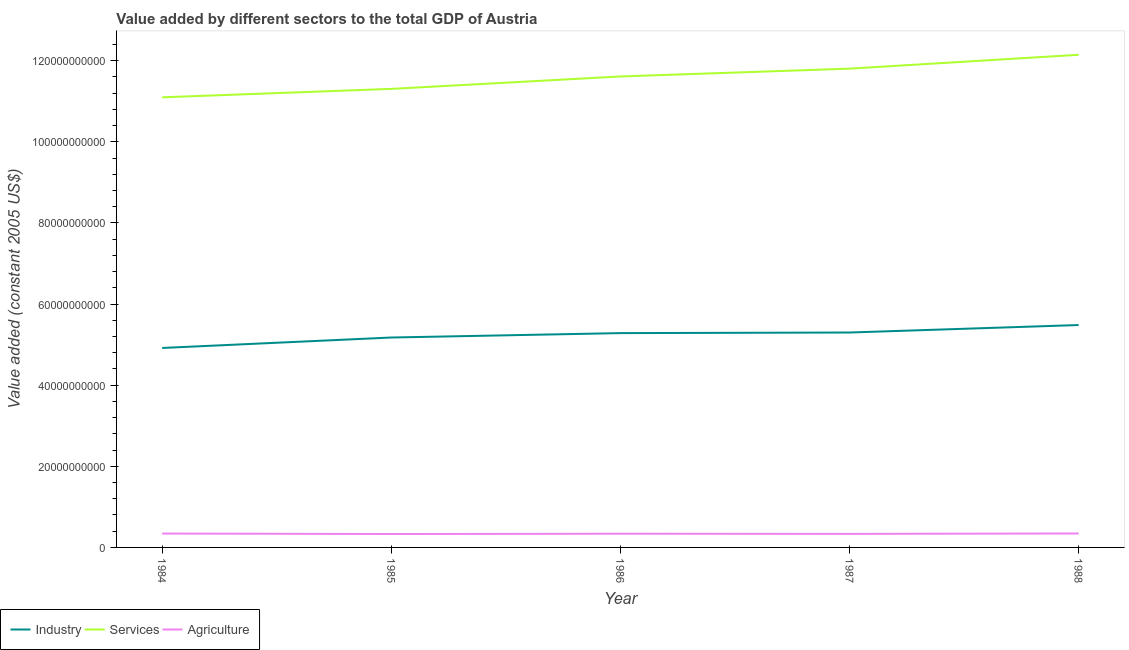How many different coloured lines are there?
Keep it short and to the point. 3. Does the line corresponding to value added by agricultural sector intersect with the line corresponding to value added by services?
Your answer should be very brief. No. What is the value added by industrial sector in 1987?
Provide a short and direct response. 5.30e+1. Across all years, what is the maximum value added by agricultural sector?
Your answer should be compact. 3.44e+09. Across all years, what is the minimum value added by services?
Offer a terse response. 1.11e+11. In which year was the value added by industrial sector minimum?
Offer a terse response. 1984. What is the total value added by agricultural sector in the graph?
Your response must be concise. 1.69e+1. What is the difference between the value added by industrial sector in 1986 and that in 1988?
Your response must be concise. -1.99e+09. What is the difference between the value added by industrial sector in 1985 and the value added by agricultural sector in 1987?
Make the answer very short. 4.84e+1. What is the average value added by industrial sector per year?
Provide a short and direct response. 5.23e+1. In the year 1987, what is the difference between the value added by industrial sector and value added by services?
Give a very brief answer. -6.51e+1. What is the ratio of the value added by agricultural sector in 1984 to that in 1987?
Your answer should be compact. 1.02. Is the difference between the value added by industrial sector in 1984 and 1985 greater than the difference between the value added by services in 1984 and 1985?
Ensure brevity in your answer.  No. What is the difference between the highest and the second highest value added by industrial sector?
Ensure brevity in your answer.  1.84e+09. What is the difference between the highest and the lowest value added by industrial sector?
Ensure brevity in your answer.  5.65e+09. Is it the case that in every year, the sum of the value added by industrial sector and value added by services is greater than the value added by agricultural sector?
Provide a succinct answer. Yes. Is the value added by services strictly greater than the value added by agricultural sector over the years?
Your response must be concise. Yes. Is the value added by services strictly less than the value added by agricultural sector over the years?
Keep it short and to the point. No. How many years are there in the graph?
Ensure brevity in your answer.  5. Are the values on the major ticks of Y-axis written in scientific E-notation?
Your answer should be compact. No. Where does the legend appear in the graph?
Make the answer very short. Bottom left. What is the title of the graph?
Provide a short and direct response. Value added by different sectors to the total GDP of Austria. Does "Infant(male)" appear as one of the legend labels in the graph?
Offer a very short reply. No. What is the label or title of the X-axis?
Provide a short and direct response. Year. What is the label or title of the Y-axis?
Provide a short and direct response. Value added (constant 2005 US$). What is the Value added (constant 2005 US$) in Industry in 1984?
Offer a terse response. 4.92e+1. What is the Value added (constant 2005 US$) in Services in 1984?
Make the answer very short. 1.11e+11. What is the Value added (constant 2005 US$) of Agriculture in 1984?
Make the answer very short. 3.42e+09. What is the Value added (constant 2005 US$) of Industry in 1985?
Your answer should be compact. 5.18e+1. What is the Value added (constant 2005 US$) in Services in 1985?
Ensure brevity in your answer.  1.13e+11. What is the Value added (constant 2005 US$) of Agriculture in 1985?
Keep it short and to the point. 3.31e+09. What is the Value added (constant 2005 US$) in Industry in 1986?
Offer a very short reply. 5.28e+1. What is the Value added (constant 2005 US$) in Services in 1986?
Ensure brevity in your answer.  1.16e+11. What is the Value added (constant 2005 US$) of Agriculture in 1986?
Offer a terse response. 3.37e+09. What is the Value added (constant 2005 US$) in Industry in 1987?
Offer a terse response. 5.30e+1. What is the Value added (constant 2005 US$) in Services in 1987?
Ensure brevity in your answer.  1.18e+11. What is the Value added (constant 2005 US$) of Agriculture in 1987?
Ensure brevity in your answer.  3.34e+09. What is the Value added (constant 2005 US$) of Industry in 1988?
Your response must be concise. 5.48e+1. What is the Value added (constant 2005 US$) in Services in 1988?
Your answer should be very brief. 1.21e+11. What is the Value added (constant 2005 US$) of Agriculture in 1988?
Your answer should be very brief. 3.44e+09. Across all years, what is the maximum Value added (constant 2005 US$) of Industry?
Your answer should be very brief. 5.48e+1. Across all years, what is the maximum Value added (constant 2005 US$) of Services?
Provide a short and direct response. 1.21e+11. Across all years, what is the maximum Value added (constant 2005 US$) of Agriculture?
Ensure brevity in your answer.  3.44e+09. Across all years, what is the minimum Value added (constant 2005 US$) of Industry?
Your answer should be compact. 4.92e+1. Across all years, what is the minimum Value added (constant 2005 US$) of Services?
Give a very brief answer. 1.11e+11. Across all years, what is the minimum Value added (constant 2005 US$) in Agriculture?
Offer a very short reply. 3.31e+09. What is the total Value added (constant 2005 US$) in Industry in the graph?
Your answer should be compact. 2.62e+11. What is the total Value added (constant 2005 US$) of Services in the graph?
Your answer should be compact. 5.80e+11. What is the total Value added (constant 2005 US$) of Agriculture in the graph?
Keep it short and to the point. 1.69e+1. What is the difference between the Value added (constant 2005 US$) of Industry in 1984 and that in 1985?
Provide a short and direct response. -2.58e+09. What is the difference between the Value added (constant 2005 US$) of Services in 1984 and that in 1985?
Your response must be concise. -2.08e+09. What is the difference between the Value added (constant 2005 US$) in Agriculture in 1984 and that in 1985?
Your answer should be very brief. 1.15e+08. What is the difference between the Value added (constant 2005 US$) in Industry in 1984 and that in 1986?
Provide a short and direct response. -3.66e+09. What is the difference between the Value added (constant 2005 US$) in Services in 1984 and that in 1986?
Provide a succinct answer. -5.14e+09. What is the difference between the Value added (constant 2005 US$) of Agriculture in 1984 and that in 1986?
Your answer should be compact. 4.65e+07. What is the difference between the Value added (constant 2005 US$) in Industry in 1984 and that in 1987?
Your answer should be compact. -3.81e+09. What is the difference between the Value added (constant 2005 US$) of Services in 1984 and that in 1987?
Offer a terse response. -7.07e+09. What is the difference between the Value added (constant 2005 US$) in Agriculture in 1984 and that in 1987?
Your response must be concise. 8.17e+07. What is the difference between the Value added (constant 2005 US$) of Industry in 1984 and that in 1988?
Ensure brevity in your answer.  -5.65e+09. What is the difference between the Value added (constant 2005 US$) in Services in 1984 and that in 1988?
Your answer should be very brief. -1.05e+1. What is the difference between the Value added (constant 2005 US$) in Agriculture in 1984 and that in 1988?
Keep it short and to the point. -2.02e+07. What is the difference between the Value added (constant 2005 US$) of Industry in 1985 and that in 1986?
Your response must be concise. -1.09e+09. What is the difference between the Value added (constant 2005 US$) in Services in 1985 and that in 1986?
Keep it short and to the point. -3.06e+09. What is the difference between the Value added (constant 2005 US$) of Agriculture in 1985 and that in 1986?
Provide a succinct answer. -6.80e+07. What is the difference between the Value added (constant 2005 US$) in Industry in 1985 and that in 1987?
Ensure brevity in your answer.  -1.23e+09. What is the difference between the Value added (constant 2005 US$) of Services in 1985 and that in 1987?
Offer a terse response. -4.99e+09. What is the difference between the Value added (constant 2005 US$) in Agriculture in 1985 and that in 1987?
Offer a very short reply. -3.29e+07. What is the difference between the Value added (constant 2005 US$) in Industry in 1985 and that in 1988?
Your answer should be compact. -3.08e+09. What is the difference between the Value added (constant 2005 US$) in Services in 1985 and that in 1988?
Provide a short and direct response. -8.41e+09. What is the difference between the Value added (constant 2005 US$) in Agriculture in 1985 and that in 1988?
Ensure brevity in your answer.  -1.35e+08. What is the difference between the Value added (constant 2005 US$) in Industry in 1986 and that in 1987?
Your response must be concise. -1.45e+08. What is the difference between the Value added (constant 2005 US$) in Services in 1986 and that in 1987?
Keep it short and to the point. -1.93e+09. What is the difference between the Value added (constant 2005 US$) of Agriculture in 1986 and that in 1987?
Provide a short and direct response. 3.51e+07. What is the difference between the Value added (constant 2005 US$) in Industry in 1986 and that in 1988?
Your answer should be very brief. -1.99e+09. What is the difference between the Value added (constant 2005 US$) in Services in 1986 and that in 1988?
Ensure brevity in your answer.  -5.35e+09. What is the difference between the Value added (constant 2005 US$) of Agriculture in 1986 and that in 1988?
Provide a succinct answer. -6.68e+07. What is the difference between the Value added (constant 2005 US$) in Industry in 1987 and that in 1988?
Offer a terse response. -1.84e+09. What is the difference between the Value added (constant 2005 US$) in Services in 1987 and that in 1988?
Keep it short and to the point. -3.42e+09. What is the difference between the Value added (constant 2005 US$) of Agriculture in 1987 and that in 1988?
Offer a very short reply. -1.02e+08. What is the difference between the Value added (constant 2005 US$) of Industry in 1984 and the Value added (constant 2005 US$) of Services in 1985?
Your response must be concise. -6.39e+1. What is the difference between the Value added (constant 2005 US$) in Industry in 1984 and the Value added (constant 2005 US$) in Agriculture in 1985?
Keep it short and to the point. 4.59e+1. What is the difference between the Value added (constant 2005 US$) in Services in 1984 and the Value added (constant 2005 US$) in Agriculture in 1985?
Your answer should be compact. 1.08e+11. What is the difference between the Value added (constant 2005 US$) of Industry in 1984 and the Value added (constant 2005 US$) of Services in 1986?
Your answer should be very brief. -6.69e+1. What is the difference between the Value added (constant 2005 US$) of Industry in 1984 and the Value added (constant 2005 US$) of Agriculture in 1986?
Your response must be concise. 4.58e+1. What is the difference between the Value added (constant 2005 US$) in Services in 1984 and the Value added (constant 2005 US$) in Agriculture in 1986?
Offer a very short reply. 1.08e+11. What is the difference between the Value added (constant 2005 US$) in Industry in 1984 and the Value added (constant 2005 US$) in Services in 1987?
Offer a very short reply. -6.89e+1. What is the difference between the Value added (constant 2005 US$) in Industry in 1984 and the Value added (constant 2005 US$) in Agriculture in 1987?
Provide a succinct answer. 4.58e+1. What is the difference between the Value added (constant 2005 US$) of Services in 1984 and the Value added (constant 2005 US$) of Agriculture in 1987?
Ensure brevity in your answer.  1.08e+11. What is the difference between the Value added (constant 2005 US$) in Industry in 1984 and the Value added (constant 2005 US$) in Services in 1988?
Give a very brief answer. -7.23e+1. What is the difference between the Value added (constant 2005 US$) of Industry in 1984 and the Value added (constant 2005 US$) of Agriculture in 1988?
Make the answer very short. 4.57e+1. What is the difference between the Value added (constant 2005 US$) in Services in 1984 and the Value added (constant 2005 US$) in Agriculture in 1988?
Make the answer very short. 1.08e+11. What is the difference between the Value added (constant 2005 US$) in Industry in 1985 and the Value added (constant 2005 US$) in Services in 1986?
Your answer should be compact. -6.44e+1. What is the difference between the Value added (constant 2005 US$) of Industry in 1985 and the Value added (constant 2005 US$) of Agriculture in 1986?
Provide a short and direct response. 4.84e+1. What is the difference between the Value added (constant 2005 US$) of Services in 1985 and the Value added (constant 2005 US$) of Agriculture in 1986?
Provide a succinct answer. 1.10e+11. What is the difference between the Value added (constant 2005 US$) in Industry in 1985 and the Value added (constant 2005 US$) in Services in 1987?
Make the answer very short. -6.63e+1. What is the difference between the Value added (constant 2005 US$) of Industry in 1985 and the Value added (constant 2005 US$) of Agriculture in 1987?
Offer a terse response. 4.84e+1. What is the difference between the Value added (constant 2005 US$) of Services in 1985 and the Value added (constant 2005 US$) of Agriculture in 1987?
Provide a succinct answer. 1.10e+11. What is the difference between the Value added (constant 2005 US$) of Industry in 1985 and the Value added (constant 2005 US$) of Services in 1988?
Make the answer very short. -6.97e+1. What is the difference between the Value added (constant 2005 US$) of Industry in 1985 and the Value added (constant 2005 US$) of Agriculture in 1988?
Your answer should be very brief. 4.83e+1. What is the difference between the Value added (constant 2005 US$) in Services in 1985 and the Value added (constant 2005 US$) in Agriculture in 1988?
Your response must be concise. 1.10e+11. What is the difference between the Value added (constant 2005 US$) in Industry in 1986 and the Value added (constant 2005 US$) in Services in 1987?
Keep it short and to the point. -6.52e+1. What is the difference between the Value added (constant 2005 US$) in Industry in 1986 and the Value added (constant 2005 US$) in Agriculture in 1987?
Provide a succinct answer. 4.95e+1. What is the difference between the Value added (constant 2005 US$) of Services in 1986 and the Value added (constant 2005 US$) of Agriculture in 1987?
Provide a short and direct response. 1.13e+11. What is the difference between the Value added (constant 2005 US$) of Industry in 1986 and the Value added (constant 2005 US$) of Services in 1988?
Make the answer very short. -6.86e+1. What is the difference between the Value added (constant 2005 US$) of Industry in 1986 and the Value added (constant 2005 US$) of Agriculture in 1988?
Provide a succinct answer. 4.94e+1. What is the difference between the Value added (constant 2005 US$) in Services in 1986 and the Value added (constant 2005 US$) in Agriculture in 1988?
Provide a short and direct response. 1.13e+11. What is the difference between the Value added (constant 2005 US$) in Industry in 1987 and the Value added (constant 2005 US$) in Services in 1988?
Ensure brevity in your answer.  -6.85e+1. What is the difference between the Value added (constant 2005 US$) of Industry in 1987 and the Value added (constant 2005 US$) of Agriculture in 1988?
Offer a very short reply. 4.95e+1. What is the difference between the Value added (constant 2005 US$) of Services in 1987 and the Value added (constant 2005 US$) of Agriculture in 1988?
Your answer should be compact. 1.15e+11. What is the average Value added (constant 2005 US$) in Industry per year?
Provide a succinct answer. 5.23e+1. What is the average Value added (constant 2005 US$) in Services per year?
Offer a terse response. 1.16e+11. What is the average Value added (constant 2005 US$) of Agriculture per year?
Your answer should be compact. 3.38e+09. In the year 1984, what is the difference between the Value added (constant 2005 US$) in Industry and Value added (constant 2005 US$) in Services?
Your answer should be compact. -6.18e+1. In the year 1984, what is the difference between the Value added (constant 2005 US$) of Industry and Value added (constant 2005 US$) of Agriculture?
Your answer should be very brief. 4.58e+1. In the year 1984, what is the difference between the Value added (constant 2005 US$) in Services and Value added (constant 2005 US$) in Agriculture?
Give a very brief answer. 1.08e+11. In the year 1985, what is the difference between the Value added (constant 2005 US$) of Industry and Value added (constant 2005 US$) of Services?
Offer a terse response. -6.13e+1. In the year 1985, what is the difference between the Value added (constant 2005 US$) in Industry and Value added (constant 2005 US$) in Agriculture?
Provide a succinct answer. 4.85e+1. In the year 1985, what is the difference between the Value added (constant 2005 US$) in Services and Value added (constant 2005 US$) in Agriculture?
Offer a terse response. 1.10e+11. In the year 1986, what is the difference between the Value added (constant 2005 US$) of Industry and Value added (constant 2005 US$) of Services?
Keep it short and to the point. -6.33e+1. In the year 1986, what is the difference between the Value added (constant 2005 US$) of Industry and Value added (constant 2005 US$) of Agriculture?
Your response must be concise. 4.95e+1. In the year 1986, what is the difference between the Value added (constant 2005 US$) in Services and Value added (constant 2005 US$) in Agriculture?
Your answer should be compact. 1.13e+11. In the year 1987, what is the difference between the Value added (constant 2005 US$) of Industry and Value added (constant 2005 US$) of Services?
Your answer should be very brief. -6.51e+1. In the year 1987, what is the difference between the Value added (constant 2005 US$) in Industry and Value added (constant 2005 US$) in Agriculture?
Ensure brevity in your answer.  4.97e+1. In the year 1987, what is the difference between the Value added (constant 2005 US$) in Services and Value added (constant 2005 US$) in Agriculture?
Make the answer very short. 1.15e+11. In the year 1988, what is the difference between the Value added (constant 2005 US$) in Industry and Value added (constant 2005 US$) in Services?
Keep it short and to the point. -6.66e+1. In the year 1988, what is the difference between the Value added (constant 2005 US$) in Industry and Value added (constant 2005 US$) in Agriculture?
Ensure brevity in your answer.  5.14e+1. In the year 1988, what is the difference between the Value added (constant 2005 US$) of Services and Value added (constant 2005 US$) of Agriculture?
Offer a terse response. 1.18e+11. What is the ratio of the Value added (constant 2005 US$) in Industry in 1984 to that in 1985?
Give a very brief answer. 0.95. What is the ratio of the Value added (constant 2005 US$) in Services in 1984 to that in 1985?
Provide a succinct answer. 0.98. What is the ratio of the Value added (constant 2005 US$) in Agriculture in 1984 to that in 1985?
Ensure brevity in your answer.  1.03. What is the ratio of the Value added (constant 2005 US$) in Industry in 1984 to that in 1986?
Ensure brevity in your answer.  0.93. What is the ratio of the Value added (constant 2005 US$) in Services in 1984 to that in 1986?
Your answer should be compact. 0.96. What is the ratio of the Value added (constant 2005 US$) in Agriculture in 1984 to that in 1986?
Provide a short and direct response. 1.01. What is the ratio of the Value added (constant 2005 US$) of Industry in 1984 to that in 1987?
Offer a very short reply. 0.93. What is the ratio of the Value added (constant 2005 US$) in Services in 1984 to that in 1987?
Your response must be concise. 0.94. What is the ratio of the Value added (constant 2005 US$) of Agriculture in 1984 to that in 1987?
Provide a succinct answer. 1.02. What is the ratio of the Value added (constant 2005 US$) of Industry in 1984 to that in 1988?
Give a very brief answer. 0.9. What is the ratio of the Value added (constant 2005 US$) in Services in 1984 to that in 1988?
Your answer should be compact. 0.91. What is the ratio of the Value added (constant 2005 US$) in Agriculture in 1984 to that in 1988?
Your response must be concise. 0.99. What is the ratio of the Value added (constant 2005 US$) in Industry in 1985 to that in 1986?
Provide a short and direct response. 0.98. What is the ratio of the Value added (constant 2005 US$) of Services in 1985 to that in 1986?
Keep it short and to the point. 0.97. What is the ratio of the Value added (constant 2005 US$) in Agriculture in 1985 to that in 1986?
Provide a succinct answer. 0.98. What is the ratio of the Value added (constant 2005 US$) in Industry in 1985 to that in 1987?
Your answer should be very brief. 0.98. What is the ratio of the Value added (constant 2005 US$) in Services in 1985 to that in 1987?
Your answer should be compact. 0.96. What is the ratio of the Value added (constant 2005 US$) in Industry in 1985 to that in 1988?
Give a very brief answer. 0.94. What is the ratio of the Value added (constant 2005 US$) of Services in 1985 to that in 1988?
Offer a terse response. 0.93. What is the ratio of the Value added (constant 2005 US$) in Agriculture in 1985 to that in 1988?
Offer a terse response. 0.96. What is the ratio of the Value added (constant 2005 US$) in Industry in 1986 to that in 1987?
Your answer should be very brief. 1. What is the ratio of the Value added (constant 2005 US$) of Services in 1986 to that in 1987?
Offer a terse response. 0.98. What is the ratio of the Value added (constant 2005 US$) in Agriculture in 1986 to that in 1987?
Offer a very short reply. 1.01. What is the ratio of the Value added (constant 2005 US$) in Industry in 1986 to that in 1988?
Your response must be concise. 0.96. What is the ratio of the Value added (constant 2005 US$) in Services in 1986 to that in 1988?
Provide a succinct answer. 0.96. What is the ratio of the Value added (constant 2005 US$) of Agriculture in 1986 to that in 1988?
Give a very brief answer. 0.98. What is the ratio of the Value added (constant 2005 US$) of Industry in 1987 to that in 1988?
Your response must be concise. 0.97. What is the ratio of the Value added (constant 2005 US$) in Services in 1987 to that in 1988?
Offer a very short reply. 0.97. What is the ratio of the Value added (constant 2005 US$) in Agriculture in 1987 to that in 1988?
Your answer should be very brief. 0.97. What is the difference between the highest and the second highest Value added (constant 2005 US$) of Industry?
Offer a terse response. 1.84e+09. What is the difference between the highest and the second highest Value added (constant 2005 US$) in Services?
Offer a very short reply. 3.42e+09. What is the difference between the highest and the second highest Value added (constant 2005 US$) in Agriculture?
Keep it short and to the point. 2.02e+07. What is the difference between the highest and the lowest Value added (constant 2005 US$) in Industry?
Keep it short and to the point. 5.65e+09. What is the difference between the highest and the lowest Value added (constant 2005 US$) of Services?
Ensure brevity in your answer.  1.05e+1. What is the difference between the highest and the lowest Value added (constant 2005 US$) of Agriculture?
Offer a very short reply. 1.35e+08. 